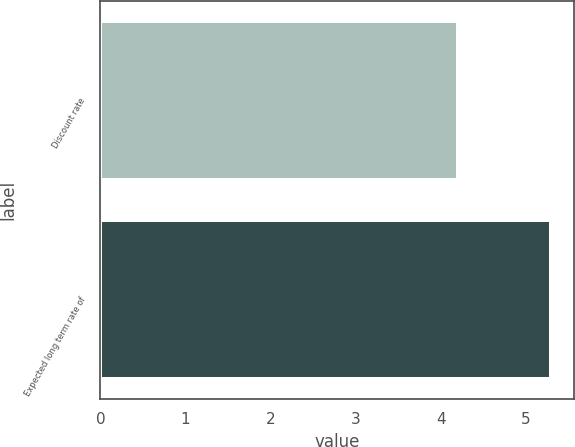<chart> <loc_0><loc_0><loc_500><loc_500><bar_chart><fcel>Discount rate<fcel>Expected long term rate of<nl><fcel>4.2<fcel>5.3<nl></chart> 